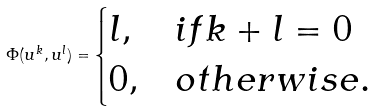Convert formula to latex. <formula><loc_0><loc_0><loc_500><loc_500>\Phi ( u ^ { k } , u ^ { l } ) = \begin{cases} l , & i f k + l = 0 \\ 0 , & o t h e r w i s e . \end{cases}</formula> 